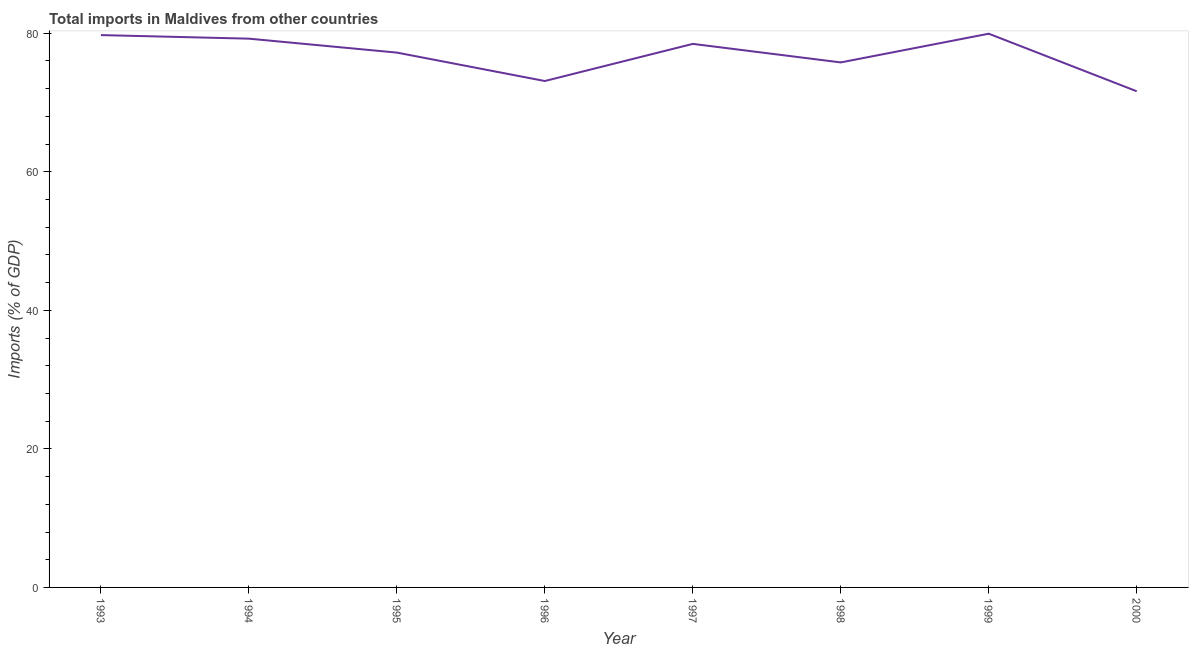What is the total imports in 1999?
Your response must be concise. 79.93. Across all years, what is the maximum total imports?
Ensure brevity in your answer.  79.93. Across all years, what is the minimum total imports?
Your response must be concise. 71.62. In which year was the total imports maximum?
Your answer should be compact. 1999. What is the sum of the total imports?
Ensure brevity in your answer.  615.01. What is the difference between the total imports in 1995 and 1996?
Keep it short and to the point. 4.1. What is the average total imports per year?
Ensure brevity in your answer.  76.88. What is the median total imports?
Provide a succinct answer. 77.83. In how many years, is the total imports greater than 4 %?
Make the answer very short. 8. Do a majority of the years between 1998 and 1999 (inclusive) have total imports greater than 36 %?
Your answer should be very brief. Yes. What is the ratio of the total imports in 1998 to that in 1999?
Make the answer very short. 0.95. Is the difference between the total imports in 1993 and 1994 greater than the difference between any two years?
Your answer should be compact. No. What is the difference between the highest and the second highest total imports?
Your answer should be very brief. 0.2. Is the sum of the total imports in 1998 and 2000 greater than the maximum total imports across all years?
Offer a very short reply. Yes. What is the difference between the highest and the lowest total imports?
Give a very brief answer. 8.31. In how many years, is the total imports greater than the average total imports taken over all years?
Provide a succinct answer. 5. Does the total imports monotonically increase over the years?
Provide a succinct answer. No. How many years are there in the graph?
Keep it short and to the point. 8. What is the difference between two consecutive major ticks on the Y-axis?
Make the answer very short. 20. Are the values on the major ticks of Y-axis written in scientific E-notation?
Make the answer very short. No. What is the title of the graph?
Your answer should be compact. Total imports in Maldives from other countries. What is the label or title of the X-axis?
Your answer should be compact. Year. What is the label or title of the Y-axis?
Ensure brevity in your answer.  Imports (% of GDP). What is the Imports (% of GDP) of 1993?
Provide a short and direct response. 79.73. What is the Imports (% of GDP) of 1994?
Make the answer very short. 79.21. What is the Imports (% of GDP) in 1995?
Offer a very short reply. 77.2. What is the Imports (% of GDP) in 1996?
Ensure brevity in your answer.  73.1. What is the Imports (% of GDP) of 1997?
Keep it short and to the point. 78.46. What is the Imports (% of GDP) in 1998?
Make the answer very short. 75.78. What is the Imports (% of GDP) of 1999?
Your answer should be very brief. 79.93. What is the Imports (% of GDP) in 2000?
Your answer should be very brief. 71.62. What is the difference between the Imports (% of GDP) in 1993 and 1994?
Provide a short and direct response. 0.52. What is the difference between the Imports (% of GDP) in 1993 and 1995?
Ensure brevity in your answer.  2.53. What is the difference between the Imports (% of GDP) in 1993 and 1996?
Keep it short and to the point. 6.63. What is the difference between the Imports (% of GDP) in 1993 and 1997?
Provide a short and direct response. 1.27. What is the difference between the Imports (% of GDP) in 1993 and 1998?
Make the answer very short. 3.94. What is the difference between the Imports (% of GDP) in 1993 and 1999?
Your answer should be compact. -0.2. What is the difference between the Imports (% of GDP) in 1993 and 2000?
Offer a very short reply. 8.11. What is the difference between the Imports (% of GDP) in 1994 and 1995?
Offer a terse response. 2.01. What is the difference between the Imports (% of GDP) in 1994 and 1996?
Keep it short and to the point. 6.11. What is the difference between the Imports (% of GDP) in 1994 and 1997?
Ensure brevity in your answer.  0.75. What is the difference between the Imports (% of GDP) in 1994 and 1998?
Provide a succinct answer. 3.43. What is the difference between the Imports (% of GDP) in 1994 and 1999?
Provide a succinct answer. -0.72. What is the difference between the Imports (% of GDP) in 1994 and 2000?
Ensure brevity in your answer.  7.59. What is the difference between the Imports (% of GDP) in 1995 and 1996?
Offer a terse response. 4.1. What is the difference between the Imports (% of GDP) in 1995 and 1997?
Keep it short and to the point. -1.26. What is the difference between the Imports (% of GDP) in 1995 and 1998?
Your answer should be compact. 1.42. What is the difference between the Imports (% of GDP) in 1995 and 1999?
Your answer should be very brief. -2.73. What is the difference between the Imports (% of GDP) in 1995 and 2000?
Offer a very short reply. 5.58. What is the difference between the Imports (% of GDP) in 1996 and 1997?
Provide a short and direct response. -5.36. What is the difference between the Imports (% of GDP) in 1996 and 1998?
Offer a terse response. -2.69. What is the difference between the Imports (% of GDP) in 1996 and 1999?
Give a very brief answer. -6.83. What is the difference between the Imports (% of GDP) in 1996 and 2000?
Your answer should be very brief. 1.48. What is the difference between the Imports (% of GDP) in 1997 and 1998?
Provide a succinct answer. 2.67. What is the difference between the Imports (% of GDP) in 1997 and 1999?
Your answer should be compact. -1.47. What is the difference between the Imports (% of GDP) in 1997 and 2000?
Offer a terse response. 6.84. What is the difference between the Imports (% of GDP) in 1998 and 1999?
Offer a very short reply. -4.14. What is the difference between the Imports (% of GDP) in 1998 and 2000?
Your answer should be compact. 4.16. What is the difference between the Imports (% of GDP) in 1999 and 2000?
Your response must be concise. 8.31. What is the ratio of the Imports (% of GDP) in 1993 to that in 1994?
Offer a very short reply. 1.01. What is the ratio of the Imports (% of GDP) in 1993 to that in 1995?
Make the answer very short. 1.03. What is the ratio of the Imports (% of GDP) in 1993 to that in 1996?
Make the answer very short. 1.09. What is the ratio of the Imports (% of GDP) in 1993 to that in 1998?
Keep it short and to the point. 1.05. What is the ratio of the Imports (% of GDP) in 1993 to that in 1999?
Your answer should be compact. 1. What is the ratio of the Imports (% of GDP) in 1993 to that in 2000?
Offer a very short reply. 1.11. What is the ratio of the Imports (% of GDP) in 1994 to that in 1996?
Your answer should be compact. 1.08. What is the ratio of the Imports (% of GDP) in 1994 to that in 1997?
Your answer should be compact. 1.01. What is the ratio of the Imports (% of GDP) in 1994 to that in 1998?
Offer a terse response. 1.04. What is the ratio of the Imports (% of GDP) in 1994 to that in 2000?
Your answer should be very brief. 1.11. What is the ratio of the Imports (% of GDP) in 1995 to that in 1996?
Make the answer very short. 1.06. What is the ratio of the Imports (% of GDP) in 1995 to that in 1997?
Keep it short and to the point. 0.98. What is the ratio of the Imports (% of GDP) in 1995 to that in 1998?
Offer a very short reply. 1.02. What is the ratio of the Imports (% of GDP) in 1995 to that in 1999?
Offer a terse response. 0.97. What is the ratio of the Imports (% of GDP) in 1995 to that in 2000?
Offer a terse response. 1.08. What is the ratio of the Imports (% of GDP) in 1996 to that in 1997?
Offer a very short reply. 0.93. What is the ratio of the Imports (% of GDP) in 1996 to that in 1999?
Your answer should be compact. 0.92. What is the ratio of the Imports (% of GDP) in 1996 to that in 2000?
Give a very brief answer. 1.02. What is the ratio of the Imports (% of GDP) in 1997 to that in 1998?
Give a very brief answer. 1.03. What is the ratio of the Imports (% of GDP) in 1997 to that in 2000?
Keep it short and to the point. 1.09. What is the ratio of the Imports (% of GDP) in 1998 to that in 1999?
Provide a succinct answer. 0.95. What is the ratio of the Imports (% of GDP) in 1998 to that in 2000?
Offer a very short reply. 1.06. What is the ratio of the Imports (% of GDP) in 1999 to that in 2000?
Make the answer very short. 1.12. 